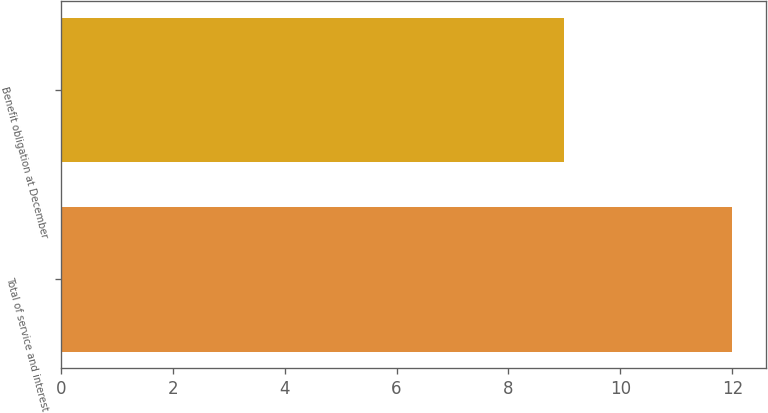Convert chart. <chart><loc_0><loc_0><loc_500><loc_500><bar_chart><fcel>Total of service and interest<fcel>Benefit obligation at December<nl><fcel>12<fcel>9<nl></chart> 